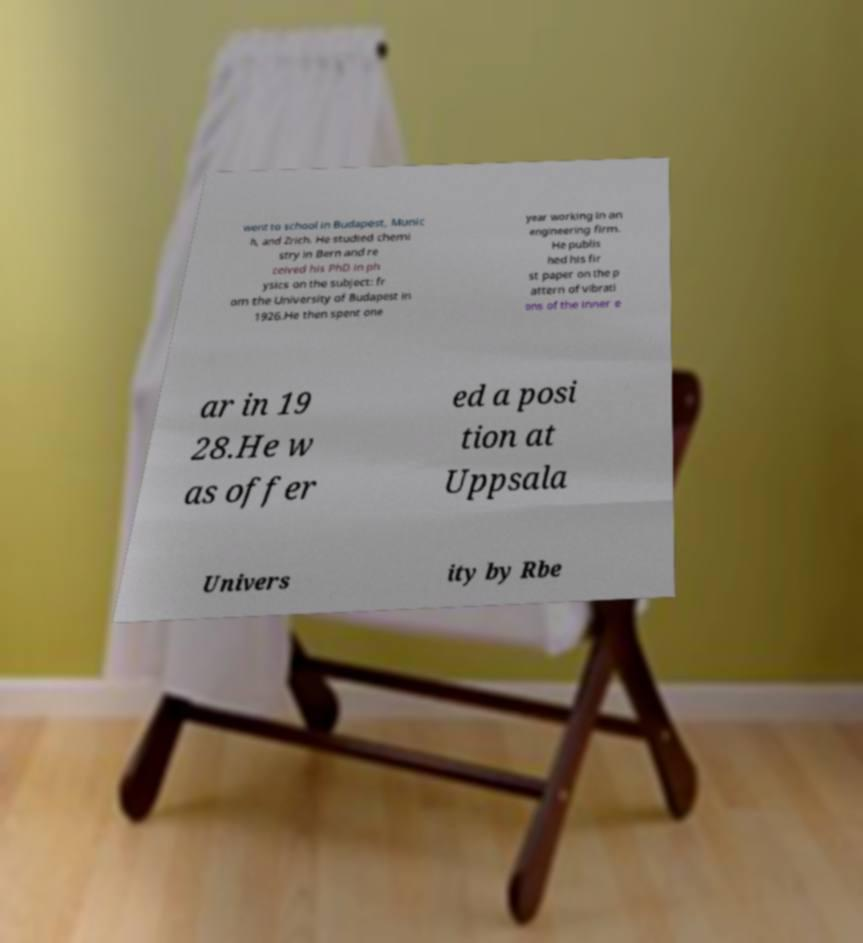Could you assist in decoding the text presented in this image and type it out clearly? went to school in Budapest, Munic h, and Zrich. He studied chemi stry in Bern and re ceived his PhD in ph ysics on the subject: fr om the University of Budapest in 1926.He then spent one year working in an engineering firm. He publis hed his fir st paper on the p attern of vibrati ons of the inner e ar in 19 28.He w as offer ed a posi tion at Uppsala Univers ity by Rbe 